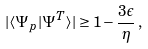<formula> <loc_0><loc_0><loc_500><loc_500>| \langle \Psi _ { p } | \Psi ^ { T } \rangle | \geq 1 - \frac { 3 \epsilon } { \eta } \, ,</formula> 